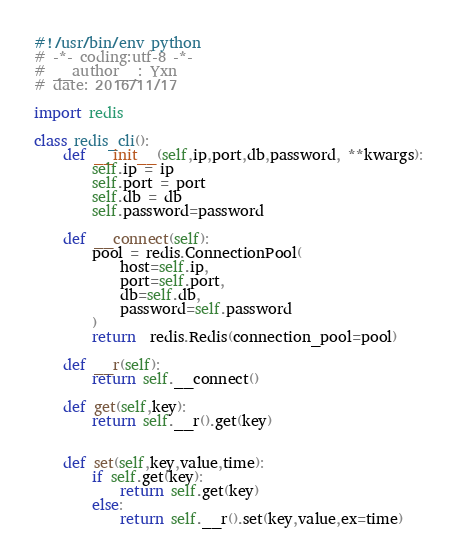<code> <loc_0><loc_0><loc_500><loc_500><_Python_>#!/usr/bin/env python
# -*- coding:utf-8 -*-
# __author__: Yxn
# date: 2016/11/17

import redis

class redis_cli():
    def __init__(self,ip,port,db,password, **kwargs):
        self.ip = ip
        self.port = port
        self.db = db
        self.password=password

    def __connect(self):
        pool = redis.ConnectionPool(
            host=self.ip,
            port=self.port,
            db=self.db,
            password=self.password
        )
        return  redis.Redis(connection_pool=pool)

    def __r(self):
        return self.__connect()

    def get(self,key):
        return self.__r().get(key)


    def set(self,key,value,time):
        if self.get(key):
            return self.get(key)
        else:
            return self.__r().set(key,value,ex=time)
</code> 